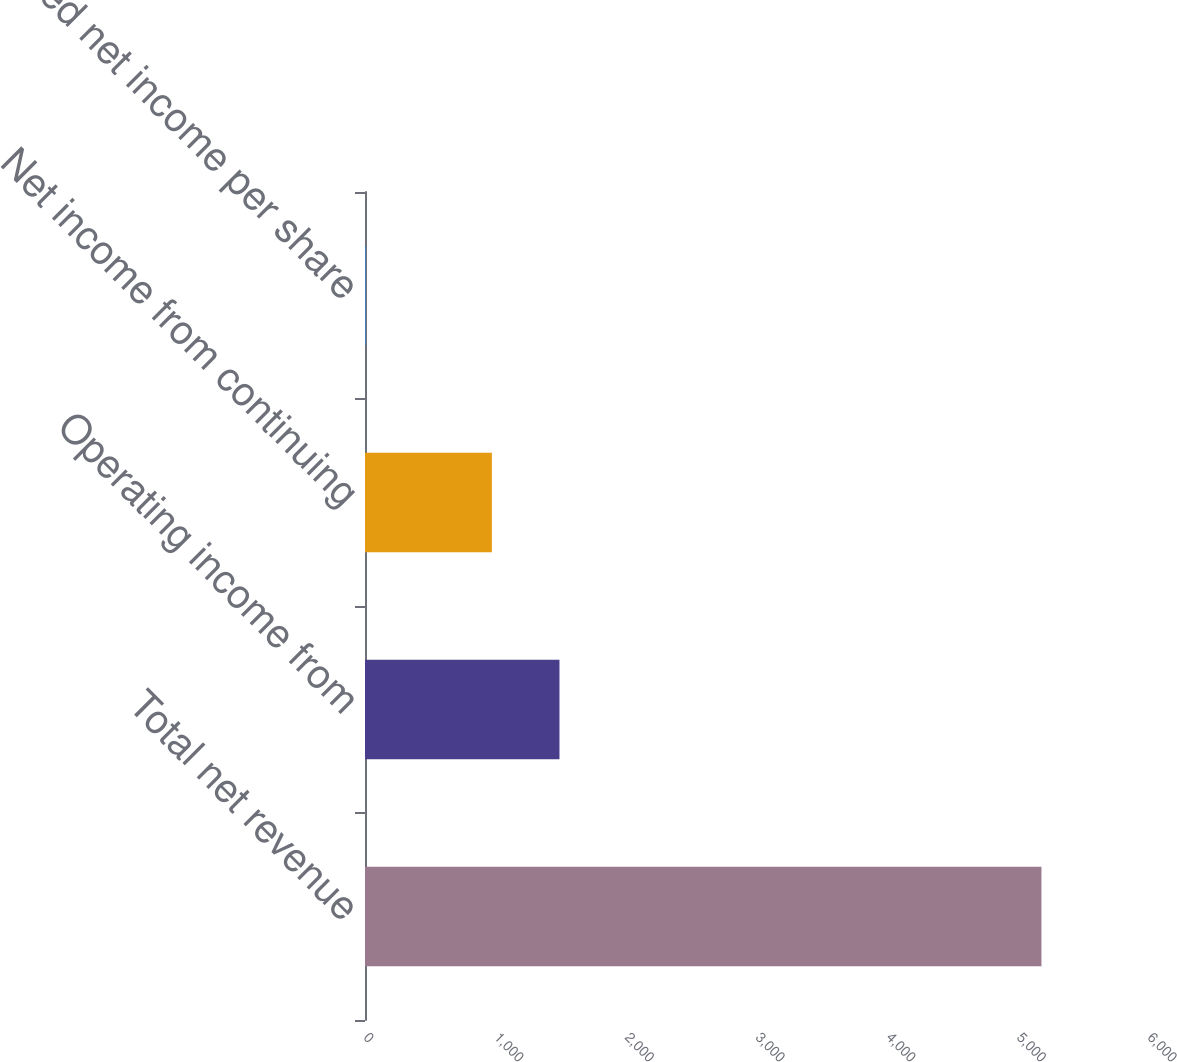<chart> <loc_0><loc_0><loc_500><loc_500><bar_chart><fcel>Total net revenue<fcel>Operating income from<fcel>Net income from continuing<fcel>Diluted net income per share<nl><fcel>5177<fcel>1488.33<fcel>971<fcel>3.72<nl></chart> 